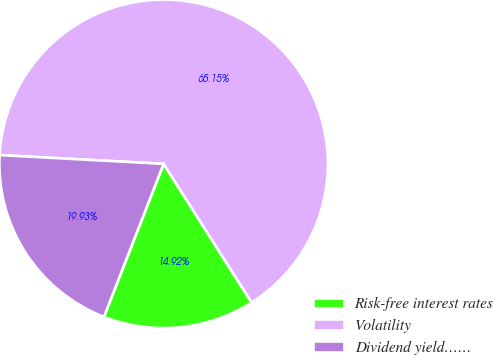Convert chart. <chart><loc_0><loc_0><loc_500><loc_500><pie_chart><fcel>Risk-free interest rates<fcel>Volatility<fcel>Dividend yield……<nl><fcel>14.92%<fcel>65.15%<fcel>19.93%<nl></chart> 